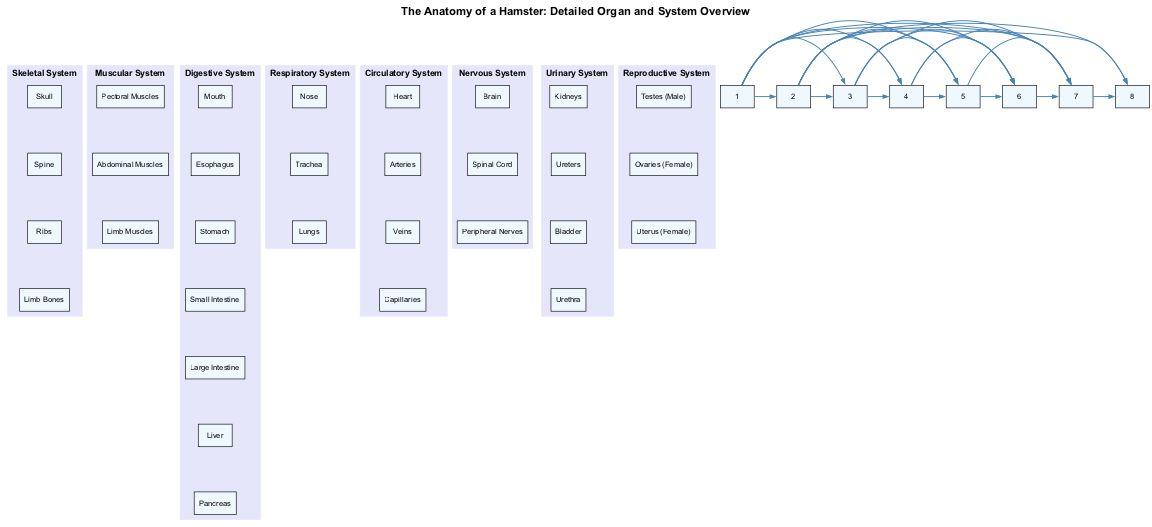What are the main systems listed in the diagram? The main systems are: Skeletal System, Muscular System, Digestive System, Respiratory System, Circulatory System, Nervous System, Urinary System, and Reproductive System. Each system represents a key area in hamster anatomy.
Answer: Skeletal System, Muscular System, Digestive System, Respiratory System, Circulatory System, Nervous System, Urinary System, Reproductive System How many organs are in the Digestive System? The Digestive System includes: Mouth, Esophagus, Stomach, Small Intestine, Large Intestine, Liver, and Pancreas. Counting these gives a total of seven organs.
Answer: 7 Which system does the Liver belong to? The Liver is one of the organs in the Digestive System, which handles the breakdown of food and nutrient absorption in hamsters.
Answer: Digestive System What connects the Skeletal System and the Muscular System? The diagram shows edges between the Skeletal System and the Muscular System, indicating their relationship. Muscles attach to bones, allowing movement, hence their direct connection.
Answer: Muscles Which organ is listed directly under the Urinary System? The Urinary System includes Kidneys, Ureters, Bladder, and Urethra. The first organ listed under this system is Kidneys.
Answer: Kidneys How many connections does the Nervous System have to other systems? The Nervous System connects to the Skeletal, Muscular, Digestive, Respiratory, Circulatory, and Urinary Systems, totaling six connections to other systems.
Answer: 6 Name one organ that is specific to the Reproductive System. The Reproductive System has specific organs like Testes (Male), Ovaries (Female), and Uterus (Female). Any one of these can be considered a specific organ of this system.
Answer: Testes (Male) Which system do the Lungs belong to? Lungs are listed under the Respiratory System, which is responsible for gas exchange and breathing in hamsters.
Answer: Respiratory System What is the total number of systems shown in the diagram? The diagram displays a total of eight systems: Skeletal, Muscular, Digestive, Respiratory, Circulatory, Nervous, Urinary, and Reproductive Systems. Counting these results in eight systems overall.
Answer: 8 